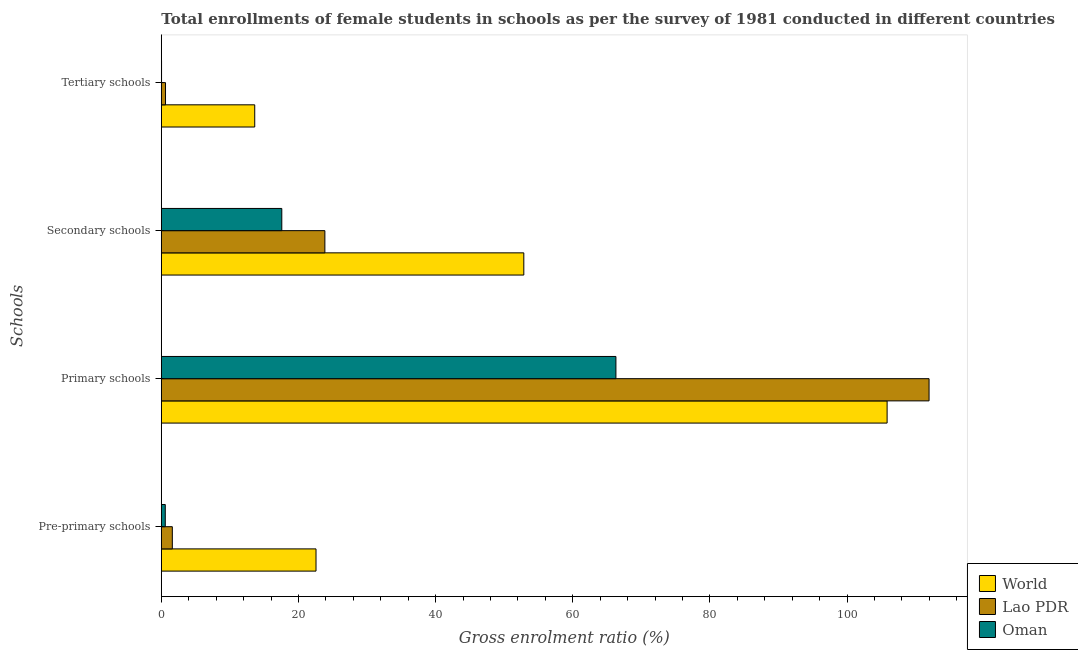Are the number of bars per tick equal to the number of legend labels?
Offer a very short reply. Yes. How many bars are there on the 4th tick from the top?
Make the answer very short. 3. How many bars are there on the 2nd tick from the bottom?
Make the answer very short. 3. What is the label of the 4th group of bars from the top?
Offer a terse response. Pre-primary schools. What is the gross enrolment ratio(female) in secondary schools in Oman?
Offer a very short reply. 17.57. Across all countries, what is the maximum gross enrolment ratio(female) in pre-primary schools?
Provide a short and direct response. 22.56. Across all countries, what is the minimum gross enrolment ratio(female) in pre-primary schools?
Keep it short and to the point. 0.58. In which country was the gross enrolment ratio(female) in pre-primary schools maximum?
Keep it short and to the point. World. In which country was the gross enrolment ratio(female) in secondary schools minimum?
Offer a terse response. Oman. What is the total gross enrolment ratio(female) in tertiary schools in the graph?
Offer a terse response. 14.27. What is the difference between the gross enrolment ratio(female) in pre-primary schools in Oman and that in Lao PDR?
Ensure brevity in your answer.  -1.03. What is the difference between the gross enrolment ratio(female) in tertiary schools in Oman and the gross enrolment ratio(female) in secondary schools in World?
Give a very brief answer. -52.83. What is the average gross enrolment ratio(female) in tertiary schools per country?
Offer a very short reply. 4.76. What is the difference between the gross enrolment ratio(female) in primary schools and gross enrolment ratio(female) in secondary schools in Lao PDR?
Offer a terse response. 88.11. What is the ratio of the gross enrolment ratio(female) in secondary schools in Oman to that in World?
Your answer should be compact. 0.33. Is the difference between the gross enrolment ratio(female) in pre-primary schools in Lao PDR and Oman greater than the difference between the gross enrolment ratio(female) in tertiary schools in Lao PDR and Oman?
Keep it short and to the point. Yes. What is the difference between the highest and the second highest gross enrolment ratio(female) in secondary schools?
Give a very brief answer. 29.01. What is the difference between the highest and the lowest gross enrolment ratio(female) in primary schools?
Provide a short and direct response. 45.66. Is the sum of the gross enrolment ratio(female) in tertiary schools in Oman and Lao PDR greater than the maximum gross enrolment ratio(female) in primary schools across all countries?
Your response must be concise. No. What does the 1st bar from the top in Tertiary schools represents?
Make the answer very short. Oman. What does the 2nd bar from the bottom in Secondary schools represents?
Provide a short and direct response. Lao PDR. Are all the bars in the graph horizontal?
Offer a very short reply. Yes. How many countries are there in the graph?
Offer a terse response. 3. What is the difference between two consecutive major ticks on the X-axis?
Ensure brevity in your answer.  20. Are the values on the major ticks of X-axis written in scientific E-notation?
Offer a terse response. No. Does the graph contain any zero values?
Keep it short and to the point. No. Does the graph contain grids?
Your answer should be compact. No. How are the legend labels stacked?
Your response must be concise. Vertical. What is the title of the graph?
Offer a very short reply. Total enrollments of female students in schools as per the survey of 1981 conducted in different countries. Does "Europe(all income levels)" appear as one of the legend labels in the graph?
Provide a short and direct response. No. What is the label or title of the X-axis?
Make the answer very short. Gross enrolment ratio (%). What is the label or title of the Y-axis?
Give a very brief answer. Schools. What is the Gross enrolment ratio (%) of World in Pre-primary schools?
Make the answer very short. 22.56. What is the Gross enrolment ratio (%) of Lao PDR in Pre-primary schools?
Your response must be concise. 1.61. What is the Gross enrolment ratio (%) of Oman in Pre-primary schools?
Your answer should be compact. 0.58. What is the Gross enrolment ratio (%) of World in Primary schools?
Provide a succinct answer. 105.84. What is the Gross enrolment ratio (%) in Lao PDR in Primary schools?
Make the answer very short. 111.96. What is the Gross enrolment ratio (%) of Oman in Primary schools?
Offer a terse response. 66.3. What is the Gross enrolment ratio (%) in World in Secondary schools?
Provide a short and direct response. 52.86. What is the Gross enrolment ratio (%) of Lao PDR in Secondary schools?
Provide a succinct answer. 23.85. What is the Gross enrolment ratio (%) of Oman in Secondary schools?
Your answer should be compact. 17.57. What is the Gross enrolment ratio (%) of World in Tertiary schools?
Keep it short and to the point. 13.62. What is the Gross enrolment ratio (%) in Lao PDR in Tertiary schools?
Make the answer very short. 0.61. What is the Gross enrolment ratio (%) in Oman in Tertiary schools?
Your answer should be very brief. 0.03. Across all Schools, what is the maximum Gross enrolment ratio (%) of World?
Provide a short and direct response. 105.84. Across all Schools, what is the maximum Gross enrolment ratio (%) in Lao PDR?
Your answer should be very brief. 111.96. Across all Schools, what is the maximum Gross enrolment ratio (%) in Oman?
Make the answer very short. 66.3. Across all Schools, what is the minimum Gross enrolment ratio (%) of World?
Keep it short and to the point. 13.62. Across all Schools, what is the minimum Gross enrolment ratio (%) of Lao PDR?
Give a very brief answer. 0.61. Across all Schools, what is the minimum Gross enrolment ratio (%) of Oman?
Make the answer very short. 0.03. What is the total Gross enrolment ratio (%) in World in the graph?
Provide a short and direct response. 194.89. What is the total Gross enrolment ratio (%) of Lao PDR in the graph?
Offer a very short reply. 138.03. What is the total Gross enrolment ratio (%) in Oman in the graph?
Make the answer very short. 84.48. What is the difference between the Gross enrolment ratio (%) of World in Pre-primary schools and that in Primary schools?
Provide a succinct answer. -83.28. What is the difference between the Gross enrolment ratio (%) in Lao PDR in Pre-primary schools and that in Primary schools?
Provide a succinct answer. -110.35. What is the difference between the Gross enrolment ratio (%) of Oman in Pre-primary schools and that in Primary schools?
Make the answer very short. -65.72. What is the difference between the Gross enrolment ratio (%) of World in Pre-primary schools and that in Secondary schools?
Make the answer very short. -30.3. What is the difference between the Gross enrolment ratio (%) in Lao PDR in Pre-primary schools and that in Secondary schools?
Your response must be concise. -22.24. What is the difference between the Gross enrolment ratio (%) in Oman in Pre-primary schools and that in Secondary schools?
Give a very brief answer. -16.99. What is the difference between the Gross enrolment ratio (%) in World in Pre-primary schools and that in Tertiary schools?
Keep it short and to the point. 8.94. What is the difference between the Gross enrolment ratio (%) in Oman in Pre-primary schools and that in Tertiary schools?
Your answer should be very brief. 0.54. What is the difference between the Gross enrolment ratio (%) of World in Primary schools and that in Secondary schools?
Provide a succinct answer. 52.98. What is the difference between the Gross enrolment ratio (%) in Lao PDR in Primary schools and that in Secondary schools?
Your answer should be compact. 88.11. What is the difference between the Gross enrolment ratio (%) of Oman in Primary schools and that in Secondary schools?
Give a very brief answer. 48.73. What is the difference between the Gross enrolment ratio (%) in World in Primary schools and that in Tertiary schools?
Ensure brevity in your answer.  92.22. What is the difference between the Gross enrolment ratio (%) in Lao PDR in Primary schools and that in Tertiary schools?
Provide a succinct answer. 111.35. What is the difference between the Gross enrolment ratio (%) of Oman in Primary schools and that in Tertiary schools?
Ensure brevity in your answer.  66.26. What is the difference between the Gross enrolment ratio (%) of World in Secondary schools and that in Tertiary schools?
Offer a very short reply. 39.24. What is the difference between the Gross enrolment ratio (%) of Lao PDR in Secondary schools and that in Tertiary schools?
Ensure brevity in your answer.  23.24. What is the difference between the Gross enrolment ratio (%) of Oman in Secondary schools and that in Tertiary schools?
Keep it short and to the point. 17.54. What is the difference between the Gross enrolment ratio (%) of World in Pre-primary schools and the Gross enrolment ratio (%) of Lao PDR in Primary schools?
Ensure brevity in your answer.  -89.4. What is the difference between the Gross enrolment ratio (%) in World in Pre-primary schools and the Gross enrolment ratio (%) in Oman in Primary schools?
Your answer should be very brief. -43.74. What is the difference between the Gross enrolment ratio (%) in Lao PDR in Pre-primary schools and the Gross enrolment ratio (%) in Oman in Primary schools?
Offer a very short reply. -64.69. What is the difference between the Gross enrolment ratio (%) in World in Pre-primary schools and the Gross enrolment ratio (%) in Lao PDR in Secondary schools?
Provide a short and direct response. -1.29. What is the difference between the Gross enrolment ratio (%) in World in Pre-primary schools and the Gross enrolment ratio (%) in Oman in Secondary schools?
Keep it short and to the point. 4.99. What is the difference between the Gross enrolment ratio (%) of Lao PDR in Pre-primary schools and the Gross enrolment ratio (%) of Oman in Secondary schools?
Your response must be concise. -15.96. What is the difference between the Gross enrolment ratio (%) in World in Pre-primary schools and the Gross enrolment ratio (%) in Lao PDR in Tertiary schools?
Offer a terse response. 21.95. What is the difference between the Gross enrolment ratio (%) of World in Pre-primary schools and the Gross enrolment ratio (%) of Oman in Tertiary schools?
Give a very brief answer. 22.52. What is the difference between the Gross enrolment ratio (%) of Lao PDR in Pre-primary schools and the Gross enrolment ratio (%) of Oman in Tertiary schools?
Offer a terse response. 1.57. What is the difference between the Gross enrolment ratio (%) in World in Primary schools and the Gross enrolment ratio (%) in Lao PDR in Secondary schools?
Offer a terse response. 81.99. What is the difference between the Gross enrolment ratio (%) of World in Primary schools and the Gross enrolment ratio (%) of Oman in Secondary schools?
Keep it short and to the point. 88.27. What is the difference between the Gross enrolment ratio (%) of Lao PDR in Primary schools and the Gross enrolment ratio (%) of Oman in Secondary schools?
Offer a very short reply. 94.39. What is the difference between the Gross enrolment ratio (%) of World in Primary schools and the Gross enrolment ratio (%) of Lao PDR in Tertiary schools?
Provide a short and direct response. 105.23. What is the difference between the Gross enrolment ratio (%) of World in Primary schools and the Gross enrolment ratio (%) of Oman in Tertiary schools?
Your answer should be compact. 105.81. What is the difference between the Gross enrolment ratio (%) of Lao PDR in Primary schools and the Gross enrolment ratio (%) of Oman in Tertiary schools?
Give a very brief answer. 111.93. What is the difference between the Gross enrolment ratio (%) in World in Secondary schools and the Gross enrolment ratio (%) in Lao PDR in Tertiary schools?
Your answer should be compact. 52.25. What is the difference between the Gross enrolment ratio (%) of World in Secondary schools and the Gross enrolment ratio (%) of Oman in Tertiary schools?
Ensure brevity in your answer.  52.83. What is the difference between the Gross enrolment ratio (%) in Lao PDR in Secondary schools and the Gross enrolment ratio (%) in Oman in Tertiary schools?
Your answer should be compact. 23.82. What is the average Gross enrolment ratio (%) in World per Schools?
Your answer should be very brief. 48.72. What is the average Gross enrolment ratio (%) in Lao PDR per Schools?
Offer a terse response. 34.51. What is the average Gross enrolment ratio (%) in Oman per Schools?
Keep it short and to the point. 21.12. What is the difference between the Gross enrolment ratio (%) of World and Gross enrolment ratio (%) of Lao PDR in Pre-primary schools?
Ensure brevity in your answer.  20.95. What is the difference between the Gross enrolment ratio (%) in World and Gross enrolment ratio (%) in Oman in Pre-primary schools?
Give a very brief answer. 21.98. What is the difference between the Gross enrolment ratio (%) of Lao PDR and Gross enrolment ratio (%) of Oman in Pre-primary schools?
Provide a succinct answer. 1.03. What is the difference between the Gross enrolment ratio (%) of World and Gross enrolment ratio (%) of Lao PDR in Primary schools?
Your response must be concise. -6.12. What is the difference between the Gross enrolment ratio (%) of World and Gross enrolment ratio (%) of Oman in Primary schools?
Provide a short and direct response. 39.55. What is the difference between the Gross enrolment ratio (%) in Lao PDR and Gross enrolment ratio (%) in Oman in Primary schools?
Keep it short and to the point. 45.66. What is the difference between the Gross enrolment ratio (%) in World and Gross enrolment ratio (%) in Lao PDR in Secondary schools?
Offer a very short reply. 29.01. What is the difference between the Gross enrolment ratio (%) in World and Gross enrolment ratio (%) in Oman in Secondary schools?
Your answer should be compact. 35.29. What is the difference between the Gross enrolment ratio (%) of Lao PDR and Gross enrolment ratio (%) of Oman in Secondary schools?
Offer a terse response. 6.28. What is the difference between the Gross enrolment ratio (%) of World and Gross enrolment ratio (%) of Lao PDR in Tertiary schools?
Ensure brevity in your answer.  13.01. What is the difference between the Gross enrolment ratio (%) in World and Gross enrolment ratio (%) in Oman in Tertiary schools?
Provide a short and direct response. 13.59. What is the difference between the Gross enrolment ratio (%) of Lao PDR and Gross enrolment ratio (%) of Oman in Tertiary schools?
Provide a succinct answer. 0.58. What is the ratio of the Gross enrolment ratio (%) in World in Pre-primary schools to that in Primary schools?
Your answer should be very brief. 0.21. What is the ratio of the Gross enrolment ratio (%) of Lao PDR in Pre-primary schools to that in Primary schools?
Provide a short and direct response. 0.01. What is the ratio of the Gross enrolment ratio (%) of Oman in Pre-primary schools to that in Primary schools?
Make the answer very short. 0.01. What is the ratio of the Gross enrolment ratio (%) in World in Pre-primary schools to that in Secondary schools?
Offer a terse response. 0.43. What is the ratio of the Gross enrolment ratio (%) of Lao PDR in Pre-primary schools to that in Secondary schools?
Offer a terse response. 0.07. What is the ratio of the Gross enrolment ratio (%) of Oman in Pre-primary schools to that in Secondary schools?
Give a very brief answer. 0.03. What is the ratio of the Gross enrolment ratio (%) in World in Pre-primary schools to that in Tertiary schools?
Your answer should be very brief. 1.66. What is the ratio of the Gross enrolment ratio (%) in Lao PDR in Pre-primary schools to that in Tertiary schools?
Offer a terse response. 2.62. What is the ratio of the Gross enrolment ratio (%) of Oman in Pre-primary schools to that in Tertiary schools?
Your response must be concise. 16.62. What is the ratio of the Gross enrolment ratio (%) of World in Primary schools to that in Secondary schools?
Ensure brevity in your answer.  2. What is the ratio of the Gross enrolment ratio (%) in Lao PDR in Primary schools to that in Secondary schools?
Offer a very short reply. 4.69. What is the ratio of the Gross enrolment ratio (%) in Oman in Primary schools to that in Secondary schools?
Provide a short and direct response. 3.77. What is the ratio of the Gross enrolment ratio (%) in World in Primary schools to that in Tertiary schools?
Provide a succinct answer. 7.77. What is the ratio of the Gross enrolment ratio (%) in Lao PDR in Primary schools to that in Tertiary schools?
Offer a terse response. 182.93. What is the ratio of the Gross enrolment ratio (%) in Oman in Primary schools to that in Tertiary schools?
Keep it short and to the point. 1908.89. What is the ratio of the Gross enrolment ratio (%) of World in Secondary schools to that in Tertiary schools?
Ensure brevity in your answer.  3.88. What is the ratio of the Gross enrolment ratio (%) in Lao PDR in Secondary schools to that in Tertiary schools?
Ensure brevity in your answer.  38.97. What is the ratio of the Gross enrolment ratio (%) of Oman in Secondary schools to that in Tertiary schools?
Keep it short and to the point. 505.91. What is the difference between the highest and the second highest Gross enrolment ratio (%) of World?
Your answer should be compact. 52.98. What is the difference between the highest and the second highest Gross enrolment ratio (%) of Lao PDR?
Ensure brevity in your answer.  88.11. What is the difference between the highest and the second highest Gross enrolment ratio (%) in Oman?
Your answer should be very brief. 48.73. What is the difference between the highest and the lowest Gross enrolment ratio (%) in World?
Ensure brevity in your answer.  92.22. What is the difference between the highest and the lowest Gross enrolment ratio (%) of Lao PDR?
Your response must be concise. 111.35. What is the difference between the highest and the lowest Gross enrolment ratio (%) of Oman?
Ensure brevity in your answer.  66.26. 